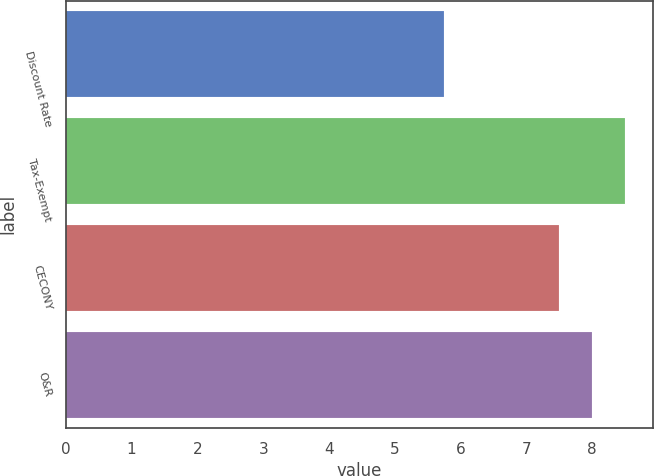Convert chart. <chart><loc_0><loc_0><loc_500><loc_500><bar_chart><fcel>Discount Rate<fcel>Tax-Exempt<fcel>CECONY<fcel>O&R<nl><fcel>5.75<fcel>8.5<fcel>7.5<fcel>8<nl></chart> 